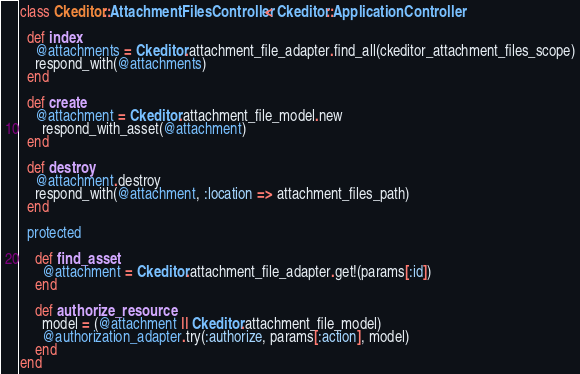<code> <loc_0><loc_0><loc_500><loc_500><_Ruby_>class Ckeditor::AttachmentFilesController < Ckeditor::ApplicationController

  def index
    @attachments = Ckeditor.attachment_file_adapter.find_all(ckeditor_attachment_files_scope)
    respond_with(@attachments)
  end
  
  def create
    @attachment = Ckeditor.attachment_file_model.new
	  respond_with_asset(@attachment)
  end
  
  def destroy
    @attachment.destroy
    respond_with(@attachment, :location => attachment_files_path)
  end
  
  protected
  
    def find_asset
      @attachment = Ckeditor.attachment_file_adapter.get!(params[:id])
    end

    def authorize_resource
      model = (@attachment || Ckeditor.attachment_file_model)
      @authorization_adapter.try(:authorize, params[:action], model)
    end
end
</code> 